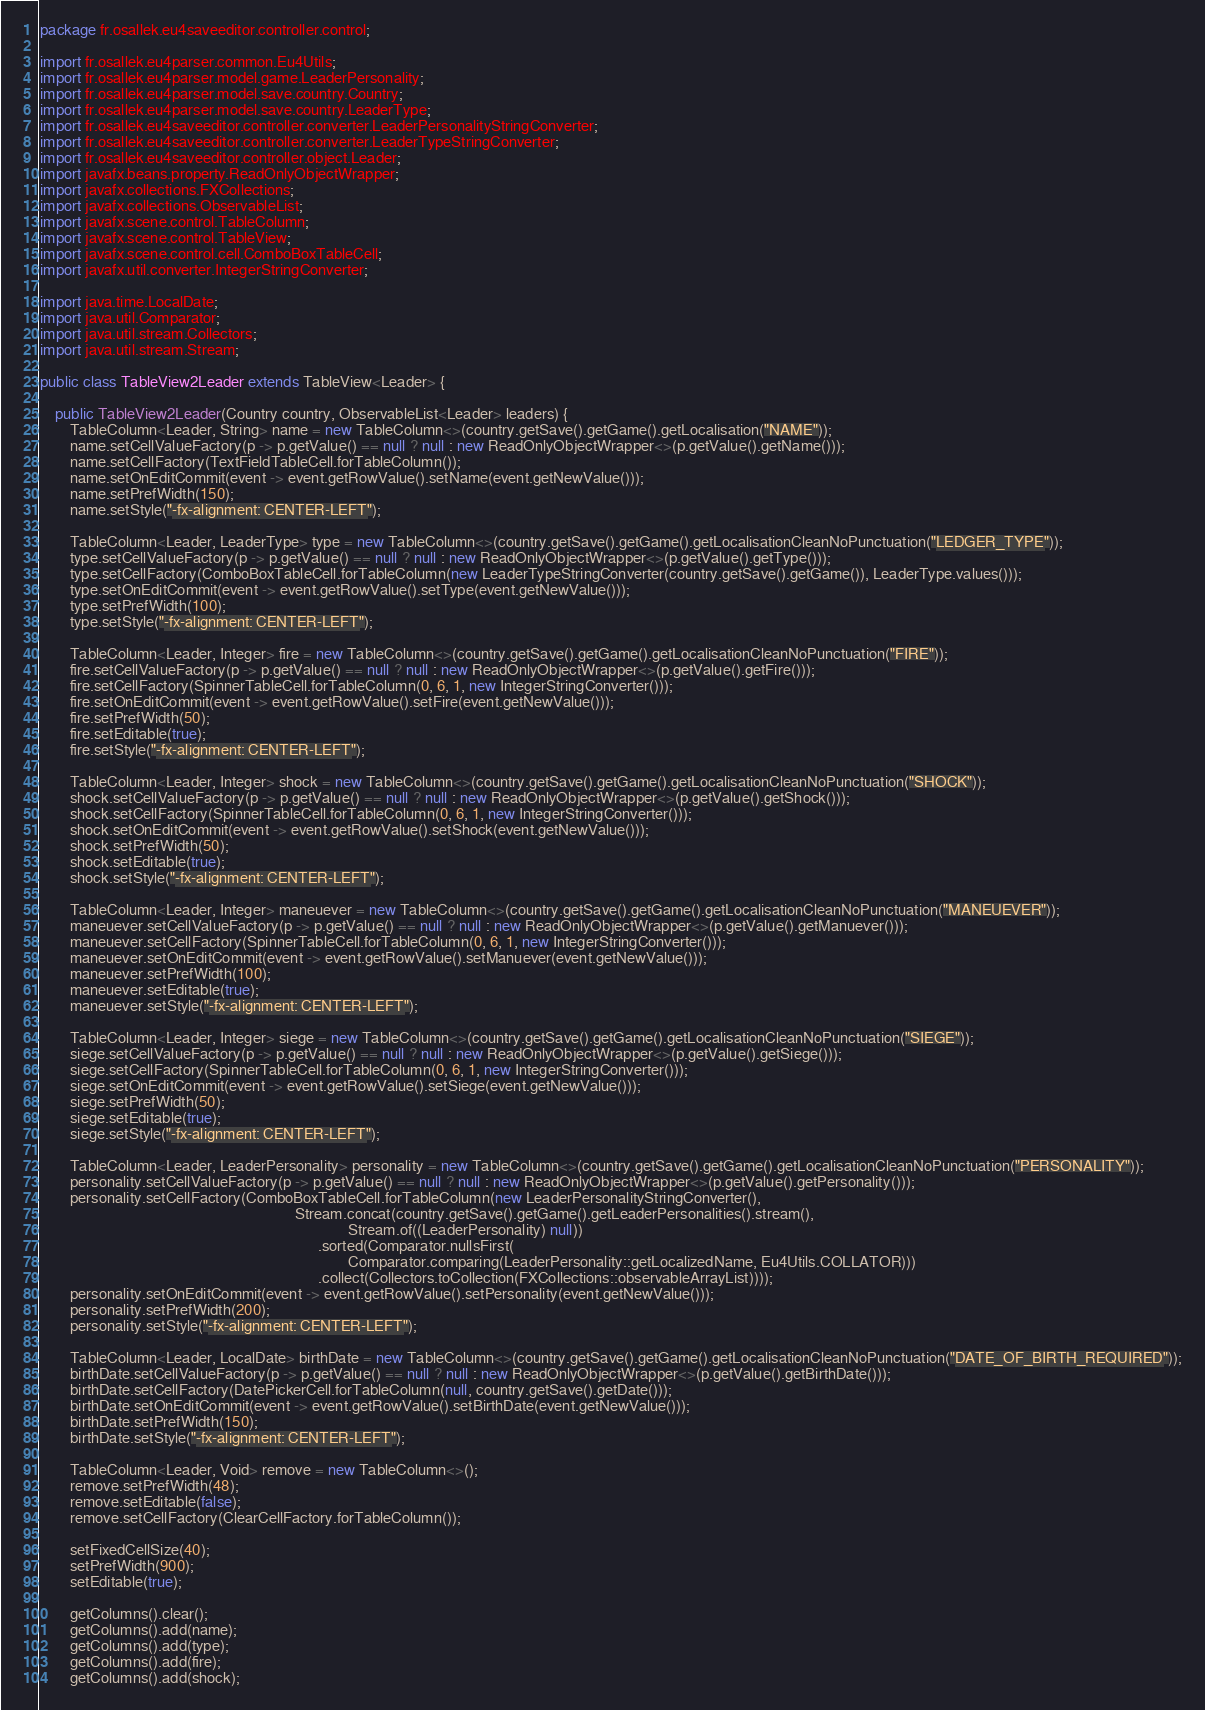<code> <loc_0><loc_0><loc_500><loc_500><_Java_>package fr.osallek.eu4saveeditor.controller.control;

import fr.osallek.eu4parser.common.Eu4Utils;
import fr.osallek.eu4parser.model.game.LeaderPersonality;
import fr.osallek.eu4parser.model.save.country.Country;
import fr.osallek.eu4parser.model.save.country.LeaderType;
import fr.osallek.eu4saveeditor.controller.converter.LeaderPersonalityStringConverter;
import fr.osallek.eu4saveeditor.controller.converter.LeaderTypeStringConverter;
import fr.osallek.eu4saveeditor.controller.object.Leader;
import javafx.beans.property.ReadOnlyObjectWrapper;
import javafx.collections.FXCollections;
import javafx.collections.ObservableList;
import javafx.scene.control.TableColumn;
import javafx.scene.control.TableView;
import javafx.scene.control.cell.ComboBoxTableCell;
import javafx.util.converter.IntegerStringConverter;

import java.time.LocalDate;
import java.util.Comparator;
import java.util.stream.Collectors;
import java.util.stream.Stream;

public class TableView2Leader extends TableView<Leader> {

    public TableView2Leader(Country country, ObservableList<Leader> leaders) {
        TableColumn<Leader, String> name = new TableColumn<>(country.getSave().getGame().getLocalisation("NAME"));
        name.setCellValueFactory(p -> p.getValue() == null ? null : new ReadOnlyObjectWrapper<>(p.getValue().getName()));
        name.setCellFactory(TextFieldTableCell.forTableColumn());
        name.setOnEditCommit(event -> event.getRowValue().setName(event.getNewValue()));
        name.setPrefWidth(150);
        name.setStyle("-fx-alignment: CENTER-LEFT");

        TableColumn<Leader, LeaderType> type = new TableColumn<>(country.getSave().getGame().getLocalisationCleanNoPunctuation("LEDGER_TYPE"));
        type.setCellValueFactory(p -> p.getValue() == null ? null : new ReadOnlyObjectWrapper<>(p.getValue().getType()));
        type.setCellFactory(ComboBoxTableCell.forTableColumn(new LeaderTypeStringConverter(country.getSave().getGame()), LeaderType.values()));
        type.setOnEditCommit(event -> event.getRowValue().setType(event.getNewValue()));
        type.setPrefWidth(100);
        type.setStyle("-fx-alignment: CENTER-LEFT");

        TableColumn<Leader, Integer> fire = new TableColumn<>(country.getSave().getGame().getLocalisationCleanNoPunctuation("FIRE"));
        fire.setCellValueFactory(p -> p.getValue() == null ? null : new ReadOnlyObjectWrapper<>(p.getValue().getFire()));
        fire.setCellFactory(SpinnerTableCell.forTableColumn(0, 6, 1, new IntegerStringConverter()));
        fire.setOnEditCommit(event -> event.getRowValue().setFire(event.getNewValue()));
        fire.setPrefWidth(50);
        fire.setEditable(true);
        fire.setStyle("-fx-alignment: CENTER-LEFT");

        TableColumn<Leader, Integer> shock = new TableColumn<>(country.getSave().getGame().getLocalisationCleanNoPunctuation("SHOCK"));
        shock.setCellValueFactory(p -> p.getValue() == null ? null : new ReadOnlyObjectWrapper<>(p.getValue().getShock()));
        shock.setCellFactory(SpinnerTableCell.forTableColumn(0, 6, 1, new IntegerStringConverter()));
        shock.setOnEditCommit(event -> event.getRowValue().setShock(event.getNewValue()));
        shock.setPrefWidth(50);
        shock.setEditable(true);
        shock.setStyle("-fx-alignment: CENTER-LEFT");

        TableColumn<Leader, Integer> maneuever = new TableColumn<>(country.getSave().getGame().getLocalisationCleanNoPunctuation("MANEUEVER"));
        maneuever.setCellValueFactory(p -> p.getValue() == null ? null : new ReadOnlyObjectWrapper<>(p.getValue().getManuever()));
        maneuever.setCellFactory(SpinnerTableCell.forTableColumn(0, 6, 1, new IntegerStringConverter()));
        maneuever.setOnEditCommit(event -> event.getRowValue().setManuever(event.getNewValue()));
        maneuever.setPrefWidth(100);
        maneuever.setEditable(true);
        maneuever.setStyle("-fx-alignment: CENTER-LEFT");

        TableColumn<Leader, Integer> siege = new TableColumn<>(country.getSave().getGame().getLocalisationCleanNoPunctuation("SIEGE"));
        siege.setCellValueFactory(p -> p.getValue() == null ? null : new ReadOnlyObjectWrapper<>(p.getValue().getSiege()));
        siege.setCellFactory(SpinnerTableCell.forTableColumn(0, 6, 1, new IntegerStringConverter()));
        siege.setOnEditCommit(event -> event.getRowValue().setSiege(event.getNewValue()));
        siege.setPrefWidth(50);
        siege.setEditable(true);
        siege.setStyle("-fx-alignment: CENTER-LEFT");

        TableColumn<Leader, LeaderPersonality> personality = new TableColumn<>(country.getSave().getGame().getLocalisationCleanNoPunctuation("PERSONALITY"));
        personality.setCellValueFactory(p -> p.getValue() == null ? null : new ReadOnlyObjectWrapper<>(p.getValue().getPersonality()));
        personality.setCellFactory(ComboBoxTableCell.forTableColumn(new LeaderPersonalityStringConverter(),
                                                                    Stream.concat(country.getSave().getGame().getLeaderPersonalities().stream(),
                                                                                  Stream.of((LeaderPersonality) null))
                                                                          .sorted(Comparator.nullsFirst(
                                                                                  Comparator.comparing(LeaderPersonality::getLocalizedName, Eu4Utils.COLLATOR)))
                                                                          .collect(Collectors.toCollection(FXCollections::observableArrayList))));
        personality.setOnEditCommit(event -> event.getRowValue().setPersonality(event.getNewValue()));
        personality.setPrefWidth(200);
        personality.setStyle("-fx-alignment: CENTER-LEFT");

        TableColumn<Leader, LocalDate> birthDate = new TableColumn<>(country.getSave().getGame().getLocalisationCleanNoPunctuation("DATE_OF_BIRTH_REQUIRED"));
        birthDate.setCellValueFactory(p -> p.getValue() == null ? null : new ReadOnlyObjectWrapper<>(p.getValue().getBirthDate()));
        birthDate.setCellFactory(DatePickerCell.forTableColumn(null, country.getSave().getDate()));
        birthDate.setOnEditCommit(event -> event.getRowValue().setBirthDate(event.getNewValue()));
        birthDate.setPrefWidth(150);
        birthDate.setStyle("-fx-alignment: CENTER-LEFT");

        TableColumn<Leader, Void> remove = new TableColumn<>();
        remove.setPrefWidth(48);
        remove.setEditable(false);
        remove.setCellFactory(ClearCellFactory.forTableColumn());

        setFixedCellSize(40);
        setPrefWidth(900);
        setEditable(true);

        getColumns().clear();
        getColumns().add(name);
        getColumns().add(type);
        getColumns().add(fire);
        getColumns().add(shock);</code> 